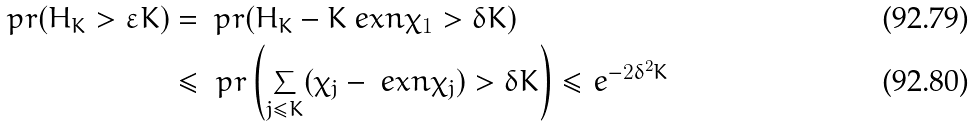Convert formula to latex. <formula><loc_0><loc_0><loc_500><loc_500>\ p r ( H _ { K } > \varepsilon K ) & = \ p r ( H _ { K } - K \ e x n \chi _ { 1 } > \delta K ) \\ & \leq \ p r \left ( \sum _ { j \leq K } ( \chi _ { j } - \ e x n \chi _ { j } ) > \delta K \right ) \leq e ^ { - 2 \delta ^ { 2 } K }</formula> 